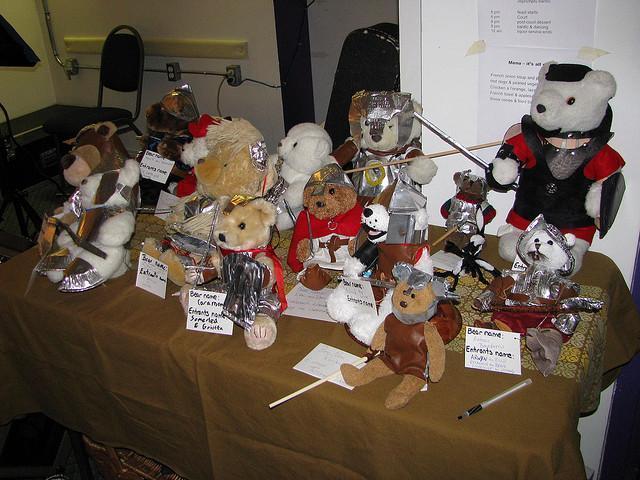How many chairs are there?
Give a very brief answer. 2. How many teddy bears are in the picture?
Give a very brief answer. 11. How many of the birds are sitting?
Give a very brief answer. 0. 